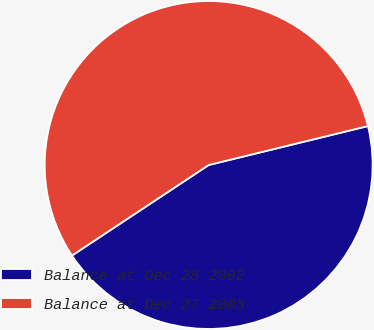Convert chart to OTSL. <chart><loc_0><loc_0><loc_500><loc_500><pie_chart><fcel>Balance at Dec 28 2002<fcel>Balance at Dec 27 2003<nl><fcel>44.51%<fcel>55.49%<nl></chart> 